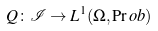Convert formula to latex. <formula><loc_0><loc_0><loc_500><loc_500>Q \colon \mathcal { I } \rightarrow L ^ { 1 } ( \Omega , \Pr o b )</formula> 